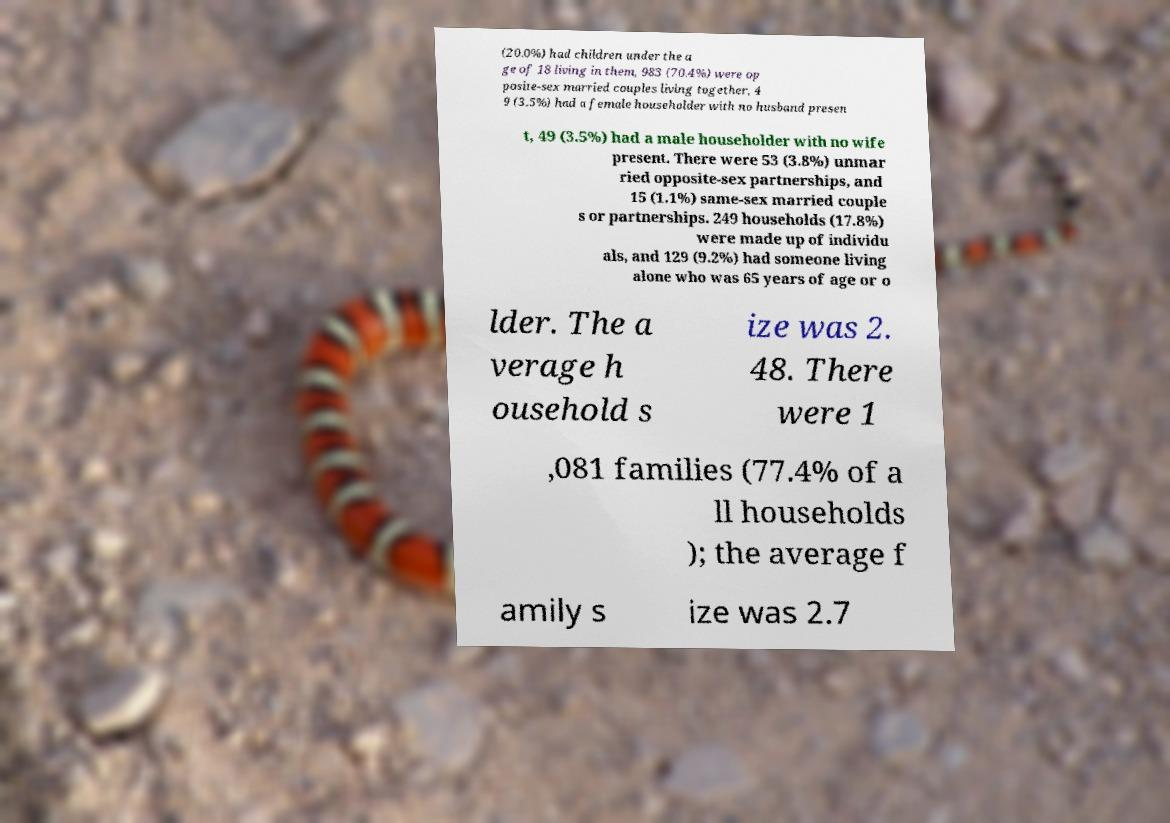I need the written content from this picture converted into text. Can you do that? (20.0%) had children under the a ge of 18 living in them, 983 (70.4%) were op posite-sex married couples living together, 4 9 (3.5%) had a female householder with no husband presen t, 49 (3.5%) had a male householder with no wife present. There were 53 (3.8%) unmar ried opposite-sex partnerships, and 15 (1.1%) same-sex married couple s or partnerships. 249 households (17.8%) were made up of individu als, and 129 (9.2%) had someone living alone who was 65 years of age or o lder. The a verage h ousehold s ize was 2. 48. There were 1 ,081 families (77.4% of a ll households ); the average f amily s ize was 2.7 